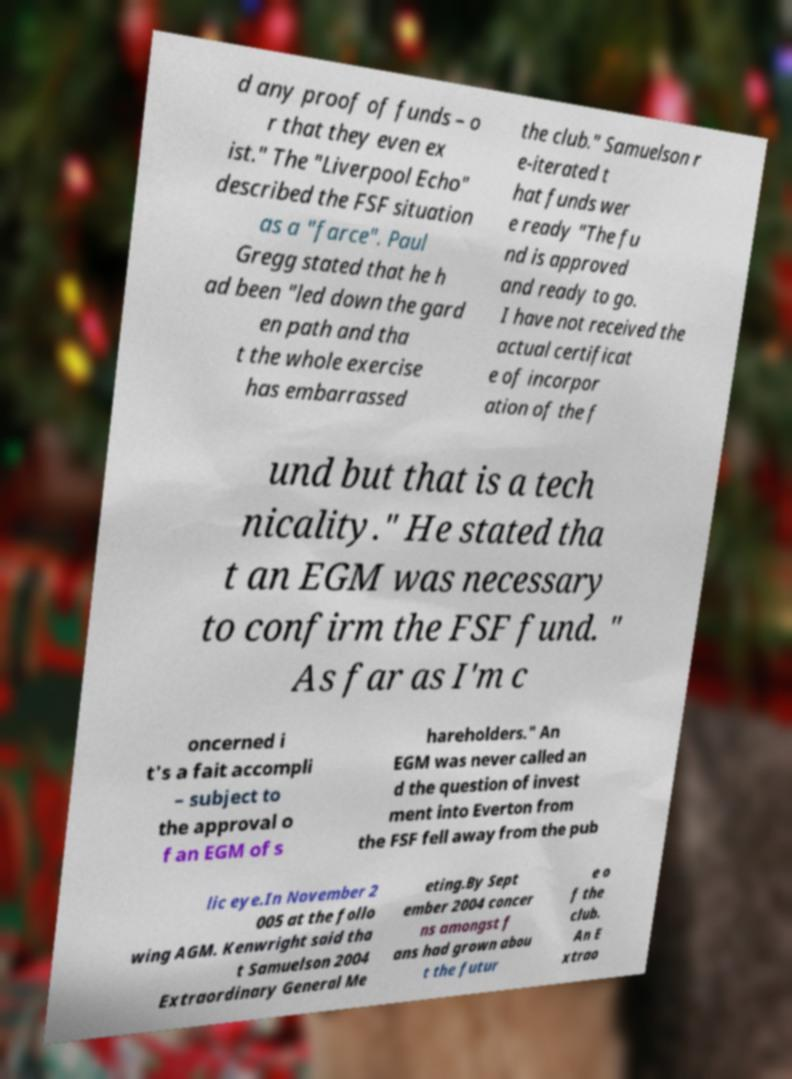Could you extract and type out the text from this image? d any proof of funds – o r that they even ex ist." The "Liverpool Echo" described the FSF situation as a "farce". Paul Gregg stated that he h ad been "led down the gard en path and tha t the whole exercise has embarrassed the club." Samuelson r e-iterated t hat funds wer e ready "The fu nd is approved and ready to go. I have not received the actual certificat e of incorpor ation of the f und but that is a tech nicality." He stated tha t an EGM was necessary to confirm the FSF fund. " As far as I'm c oncerned i t's a fait accompli – subject to the approval o f an EGM of s hareholders." An EGM was never called an d the question of invest ment into Everton from the FSF fell away from the pub lic eye.In November 2 005 at the follo wing AGM. Kenwright said tha t Samuelson 2004 Extraordinary General Me eting.By Sept ember 2004 concer ns amongst f ans had grown abou t the futur e o f the club. An E xtrao 